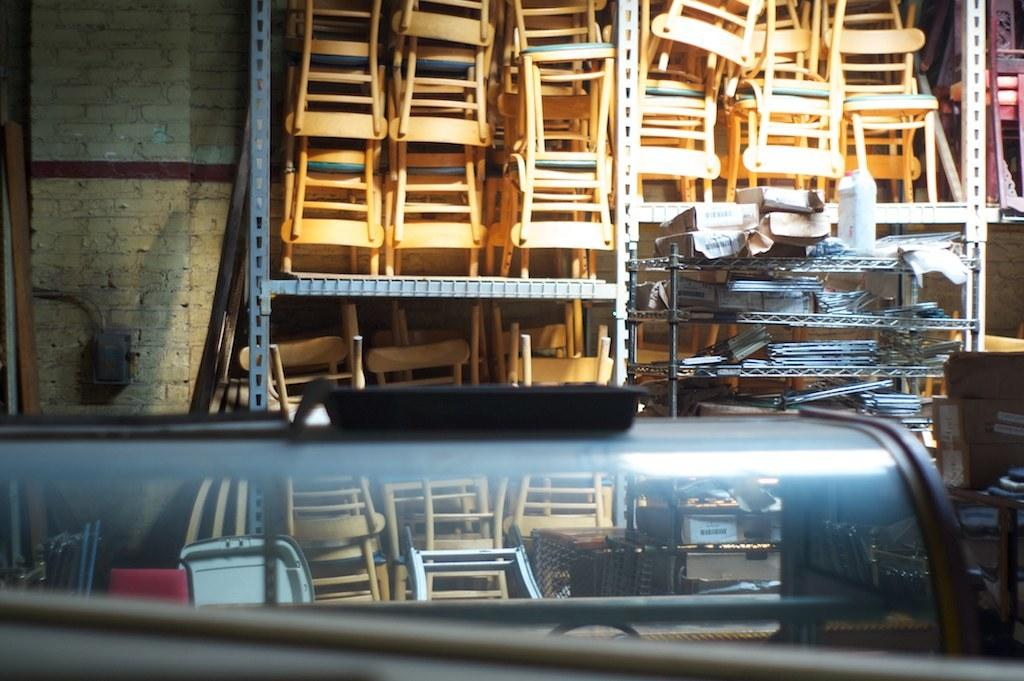What type of furniture is present in the image? There are wooden chairs in the image. How are the wooden chairs arranged? The wooden chairs are arranged in a rack. What else can be seen in the image besides the wooden chairs? There are objects placed in another rack, and one of the objects appears to be made of glass. What is visible in the background of the image? There is a wall visible in the image. Where is the brother sitting in the image? There is no brother present in the image. What type of basket can be seen holding the drain in the image? There is no basket or drain present in the image. 